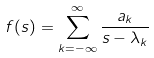Convert formula to latex. <formula><loc_0><loc_0><loc_500><loc_500>f ( s ) = \sum _ { k = - \infty } ^ { \infty } \frac { a _ { k } } { s - \lambda _ { k } }</formula> 